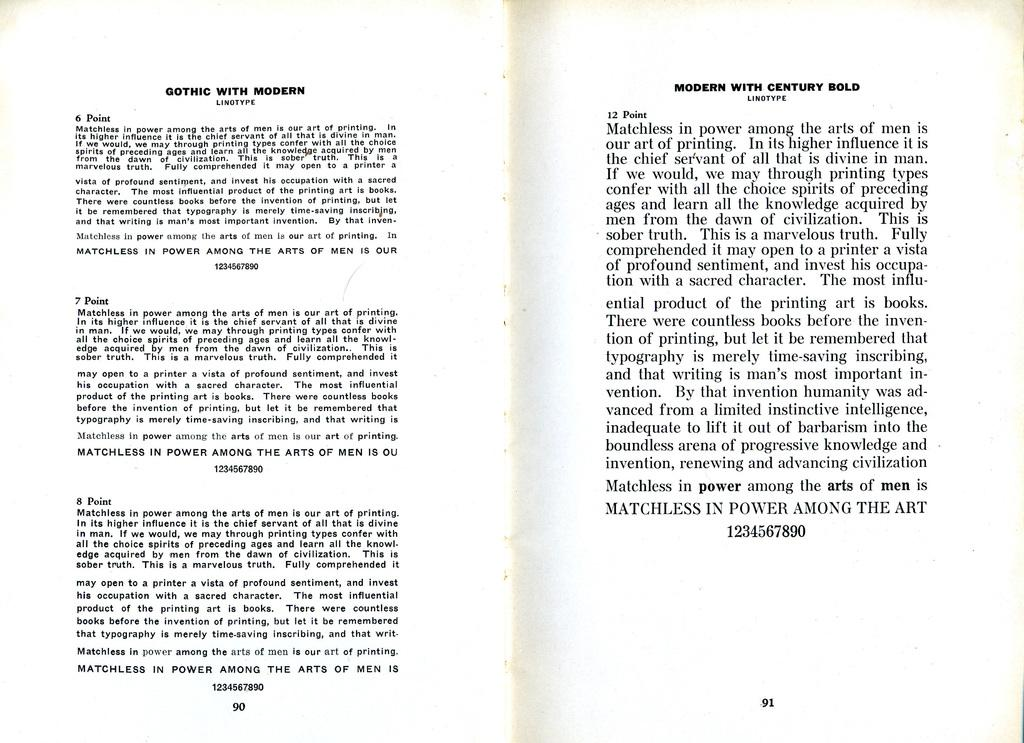<image>
Summarize the visual content of the image. the book is opened to page 90 and 91 